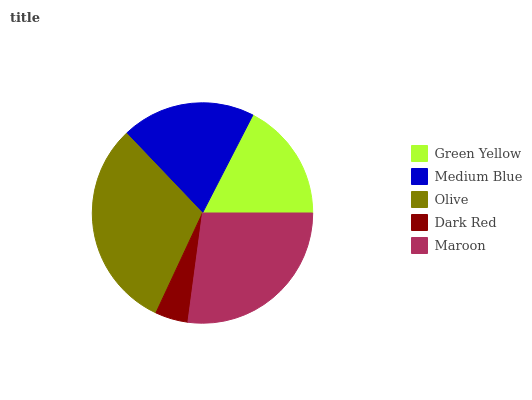Is Dark Red the minimum?
Answer yes or no. Yes. Is Olive the maximum?
Answer yes or no. Yes. Is Medium Blue the minimum?
Answer yes or no. No. Is Medium Blue the maximum?
Answer yes or no. No. Is Medium Blue greater than Green Yellow?
Answer yes or no. Yes. Is Green Yellow less than Medium Blue?
Answer yes or no. Yes. Is Green Yellow greater than Medium Blue?
Answer yes or no. No. Is Medium Blue less than Green Yellow?
Answer yes or no. No. Is Medium Blue the high median?
Answer yes or no. Yes. Is Medium Blue the low median?
Answer yes or no. Yes. Is Dark Red the high median?
Answer yes or no. No. Is Olive the low median?
Answer yes or no. No. 